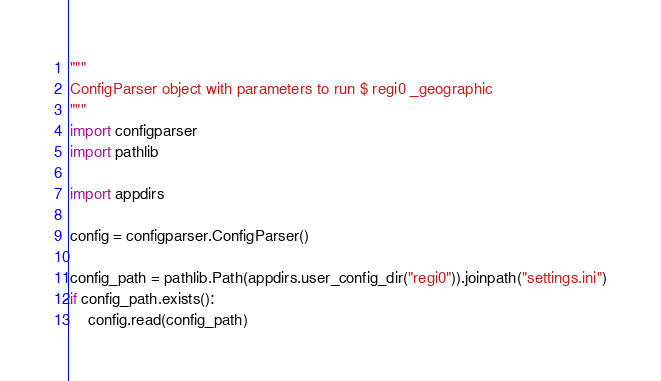<code> <loc_0><loc_0><loc_500><loc_500><_Python_>"""
ConfigParser object with parameters to run $ regi0 _geographic
"""
import configparser
import pathlib

import appdirs

config = configparser.ConfigParser()

config_path = pathlib.Path(appdirs.user_config_dir("regi0")).joinpath("settings.ini")
if config_path.exists():
    config.read(config_path)
</code> 